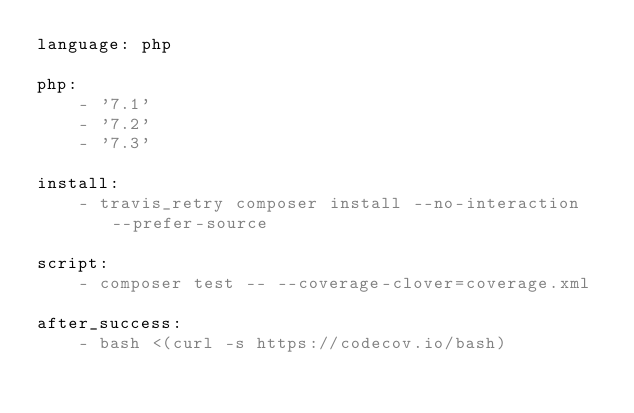<code> <loc_0><loc_0><loc_500><loc_500><_YAML_>language: php

php:
    - '7.1'
    - '7.2'
    - '7.3'

install:
    - travis_retry composer install --no-interaction --prefer-source

script:
    - composer test -- --coverage-clover=coverage.xml

after_success:
    - bash <(curl -s https://codecov.io/bash)
</code> 